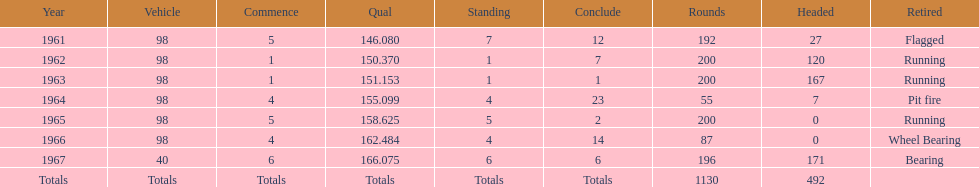Number of times to finish the races running. 3. 